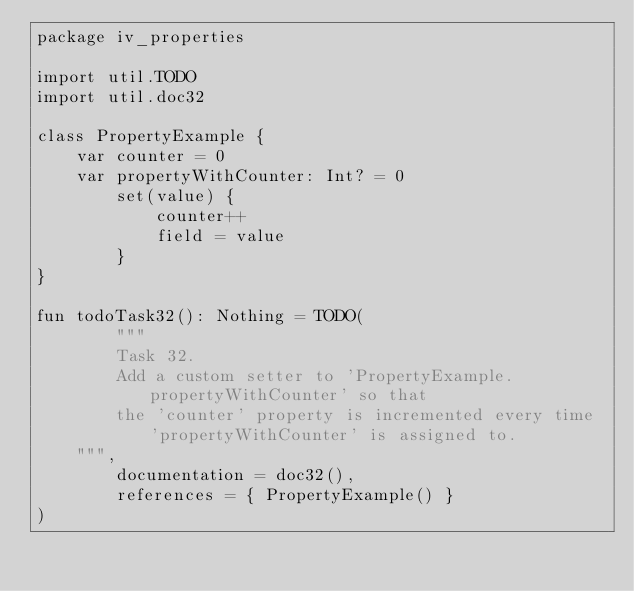<code> <loc_0><loc_0><loc_500><loc_500><_Kotlin_>package iv_properties

import util.TODO
import util.doc32

class PropertyExample {
    var counter = 0
    var propertyWithCounter: Int? = 0
        set(value) {
            counter++
            field = value
        }
}

fun todoTask32(): Nothing = TODO(
        """
        Task 32.
        Add a custom setter to 'PropertyExample.propertyWithCounter' so that
        the 'counter' property is incremented every time 'propertyWithCounter' is assigned to.
    """,
        documentation = doc32(),
        references = { PropertyExample() }
)
</code> 